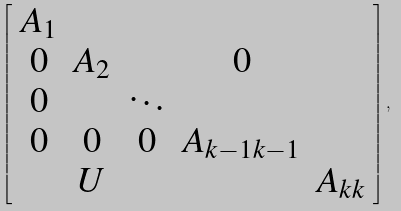<formula> <loc_0><loc_0><loc_500><loc_500>\left [ \begin{array} { c c c c c } A _ { 1 } \\ 0 & A _ { 2 } & & 0 \\ 0 & & \ddots \\ 0 & 0 & 0 & A _ { k - 1 k - 1 } \\ & U & & & A _ { k k } \end{array} \right ] ,</formula> 